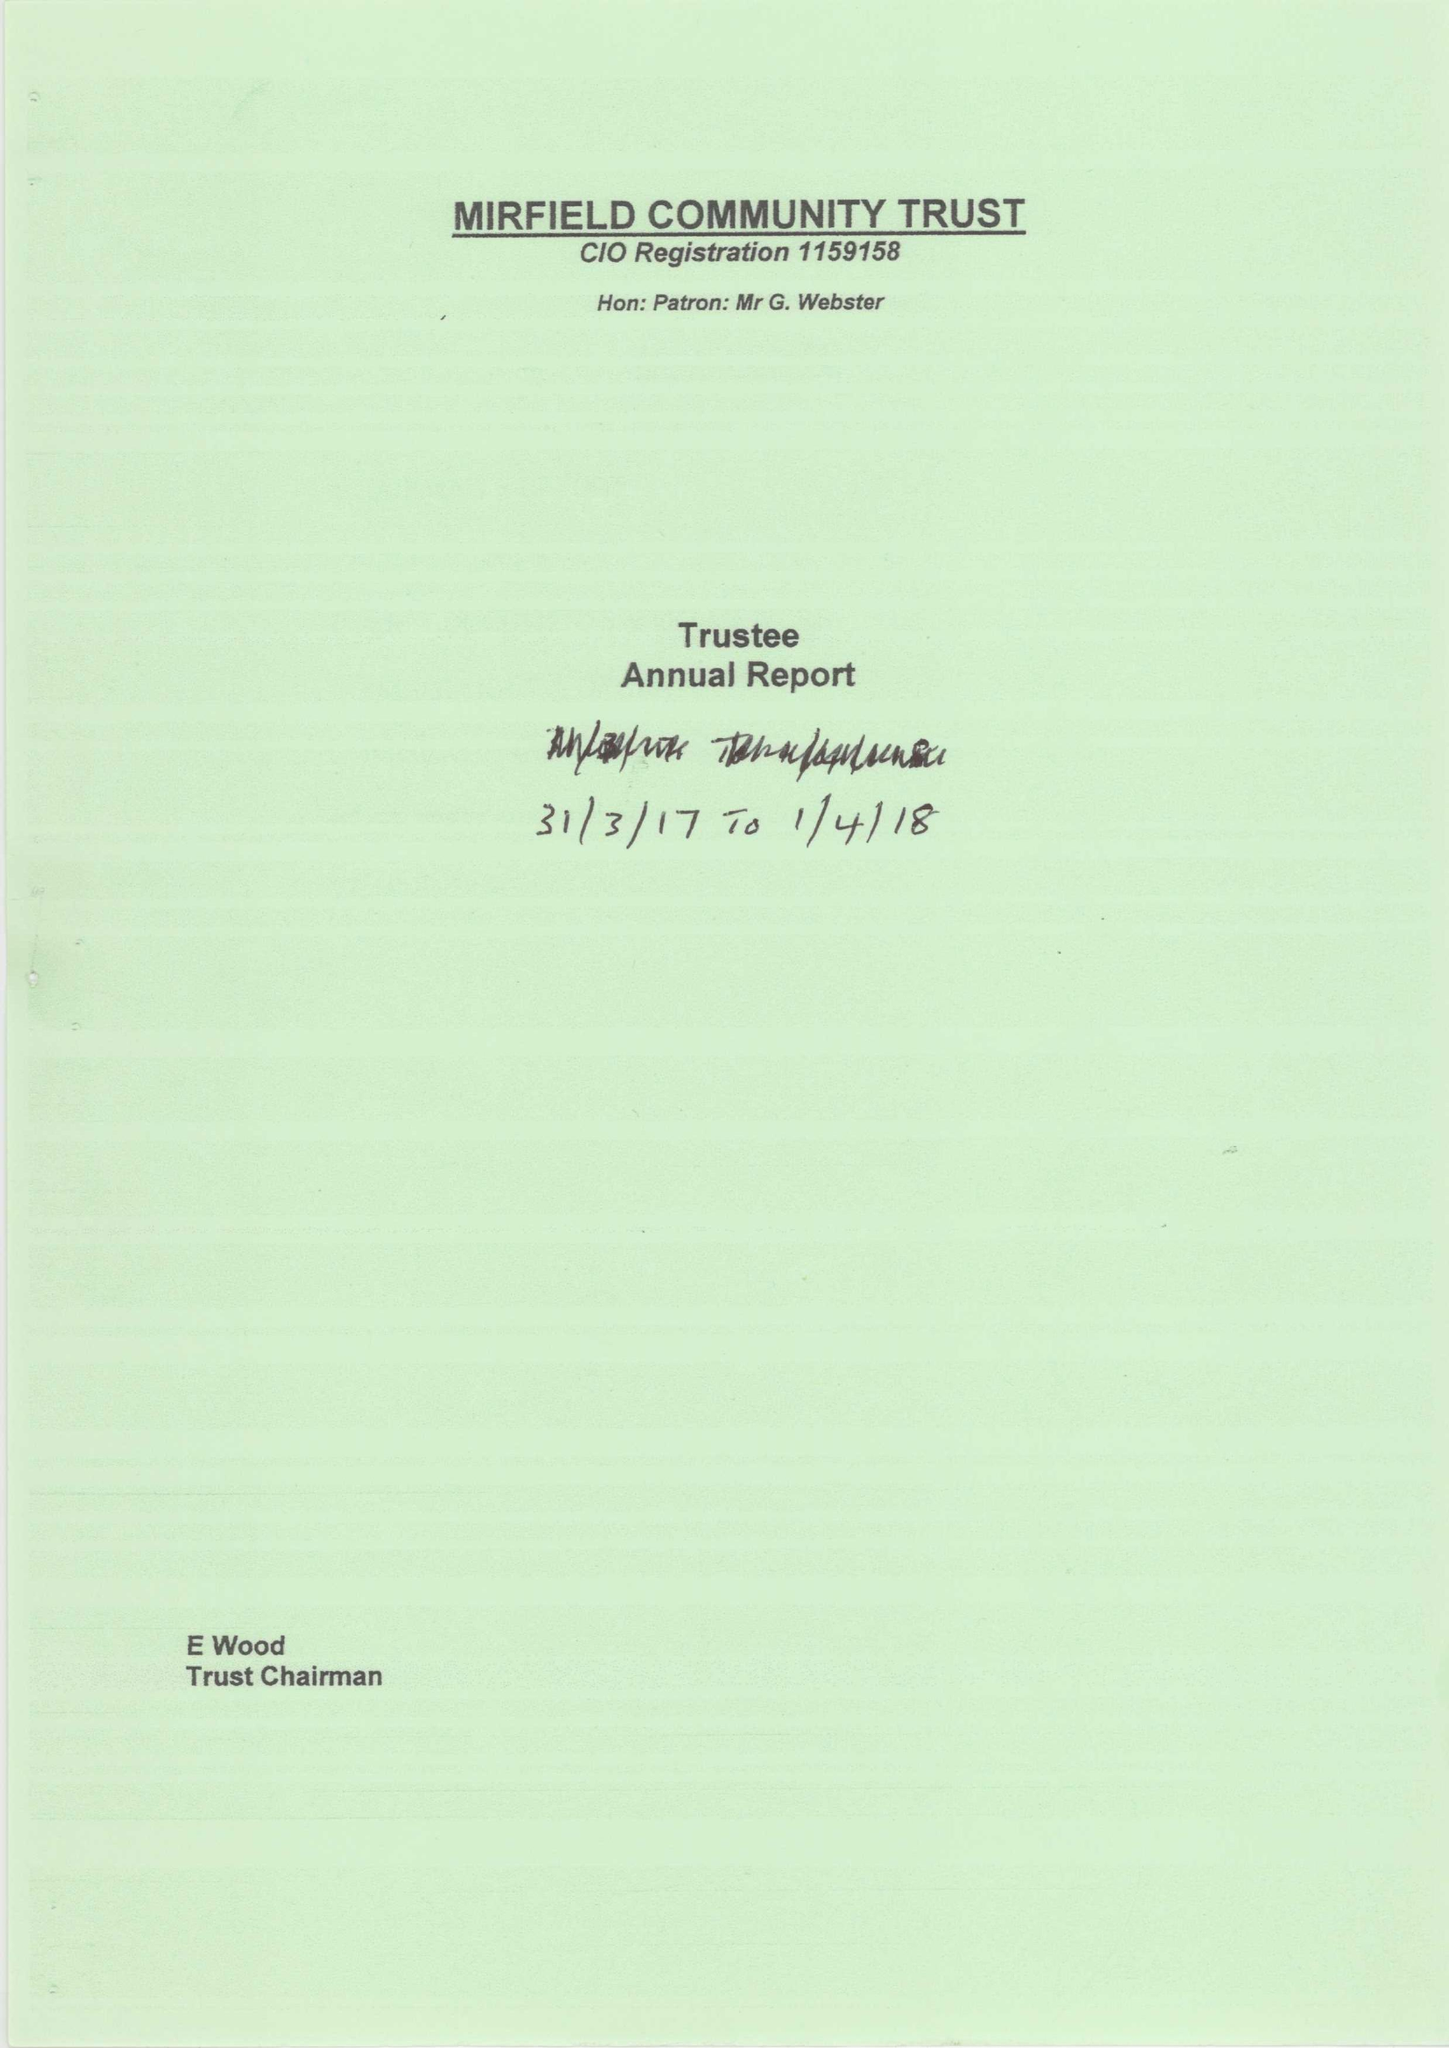What is the value for the charity_name?
Answer the question using a single word or phrase. Mirfield Community Trust 